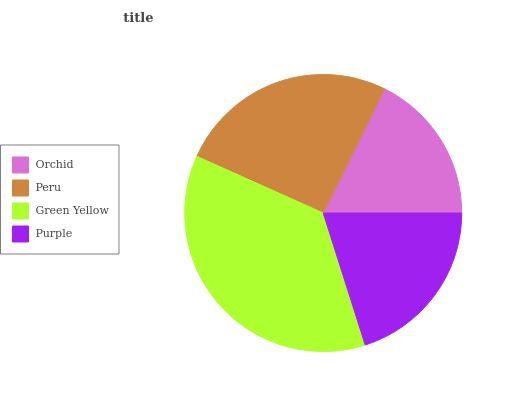Is Orchid the minimum?
Answer yes or no. Yes. Is Green Yellow the maximum?
Answer yes or no. Yes. Is Peru the minimum?
Answer yes or no. No. Is Peru the maximum?
Answer yes or no. No. Is Peru greater than Orchid?
Answer yes or no. Yes. Is Orchid less than Peru?
Answer yes or no. Yes. Is Orchid greater than Peru?
Answer yes or no. No. Is Peru less than Orchid?
Answer yes or no. No. Is Peru the high median?
Answer yes or no. Yes. Is Purple the low median?
Answer yes or no. Yes. Is Green Yellow the high median?
Answer yes or no. No. Is Orchid the low median?
Answer yes or no. No. 